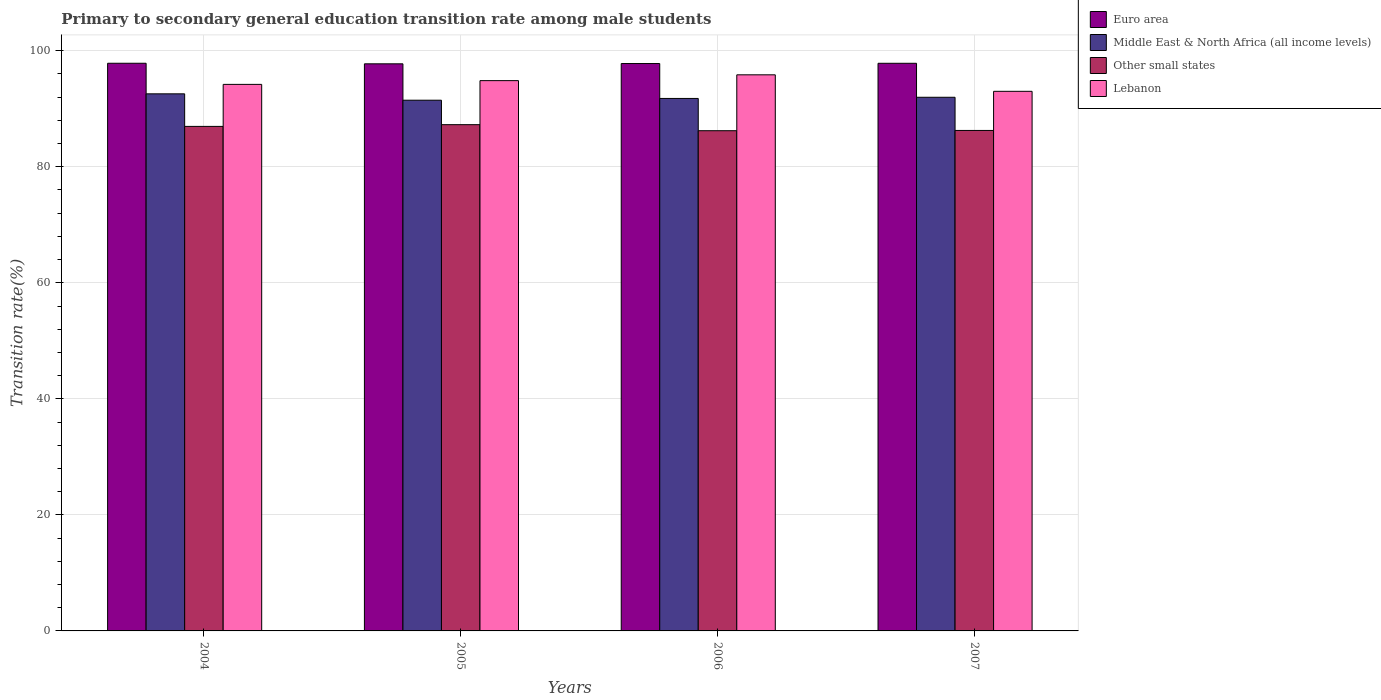How many different coloured bars are there?
Offer a terse response. 4. Are the number of bars on each tick of the X-axis equal?
Provide a succinct answer. Yes. How many bars are there on the 1st tick from the right?
Offer a very short reply. 4. What is the transition rate in Middle East & North Africa (all income levels) in 2007?
Offer a terse response. 91.98. Across all years, what is the maximum transition rate in Lebanon?
Make the answer very short. 95.85. Across all years, what is the minimum transition rate in Other small states?
Your response must be concise. 86.22. In which year was the transition rate in Euro area maximum?
Provide a short and direct response. 2004. In which year was the transition rate in Other small states minimum?
Offer a terse response. 2006. What is the total transition rate in Other small states in the graph?
Your answer should be very brief. 346.7. What is the difference between the transition rate in Middle East & North Africa (all income levels) in 2004 and that in 2006?
Offer a very short reply. 0.79. What is the difference between the transition rate in Euro area in 2005 and the transition rate in Lebanon in 2006?
Provide a succinct answer. 1.9. What is the average transition rate in Other small states per year?
Your answer should be compact. 86.68. In the year 2006, what is the difference between the transition rate in Other small states and transition rate in Middle East & North Africa (all income levels)?
Provide a short and direct response. -5.56. What is the ratio of the transition rate in Lebanon in 2005 to that in 2006?
Your answer should be compact. 0.99. What is the difference between the highest and the second highest transition rate in Euro area?
Your answer should be very brief. 0. What is the difference between the highest and the lowest transition rate in Other small states?
Your response must be concise. 1.04. In how many years, is the transition rate in Lebanon greater than the average transition rate in Lebanon taken over all years?
Ensure brevity in your answer.  2. Is it the case that in every year, the sum of the transition rate in Lebanon and transition rate in Middle East & North Africa (all income levels) is greater than the sum of transition rate in Other small states and transition rate in Euro area?
Make the answer very short. Yes. What does the 2nd bar from the left in 2006 represents?
Ensure brevity in your answer.  Middle East & North Africa (all income levels). What does the 4th bar from the right in 2004 represents?
Your answer should be compact. Euro area. How many years are there in the graph?
Give a very brief answer. 4. What is the difference between two consecutive major ticks on the Y-axis?
Your response must be concise. 20. Are the values on the major ticks of Y-axis written in scientific E-notation?
Offer a very short reply. No. Does the graph contain any zero values?
Give a very brief answer. No. Where does the legend appear in the graph?
Make the answer very short. Top right. How many legend labels are there?
Give a very brief answer. 4. How are the legend labels stacked?
Ensure brevity in your answer.  Vertical. What is the title of the graph?
Your response must be concise. Primary to secondary general education transition rate among male students. What is the label or title of the X-axis?
Keep it short and to the point. Years. What is the label or title of the Y-axis?
Ensure brevity in your answer.  Transition rate(%). What is the Transition rate(%) in Euro area in 2004?
Your response must be concise. 97.84. What is the Transition rate(%) of Middle East & North Africa (all income levels) in 2004?
Your answer should be compact. 92.57. What is the Transition rate(%) in Other small states in 2004?
Keep it short and to the point. 86.96. What is the Transition rate(%) in Lebanon in 2004?
Your answer should be compact. 94.2. What is the Transition rate(%) of Euro area in 2005?
Provide a short and direct response. 97.75. What is the Transition rate(%) of Middle East & North Africa (all income levels) in 2005?
Your response must be concise. 91.48. What is the Transition rate(%) in Other small states in 2005?
Provide a succinct answer. 87.26. What is the Transition rate(%) of Lebanon in 2005?
Provide a succinct answer. 94.85. What is the Transition rate(%) of Euro area in 2006?
Your answer should be compact. 97.79. What is the Transition rate(%) of Middle East & North Africa (all income levels) in 2006?
Make the answer very short. 91.78. What is the Transition rate(%) in Other small states in 2006?
Keep it short and to the point. 86.22. What is the Transition rate(%) in Lebanon in 2006?
Ensure brevity in your answer.  95.85. What is the Transition rate(%) in Euro area in 2007?
Give a very brief answer. 97.84. What is the Transition rate(%) in Middle East & North Africa (all income levels) in 2007?
Offer a terse response. 91.98. What is the Transition rate(%) of Other small states in 2007?
Offer a very short reply. 86.26. What is the Transition rate(%) in Lebanon in 2007?
Keep it short and to the point. 93.01. Across all years, what is the maximum Transition rate(%) in Euro area?
Give a very brief answer. 97.84. Across all years, what is the maximum Transition rate(%) in Middle East & North Africa (all income levels)?
Provide a succinct answer. 92.57. Across all years, what is the maximum Transition rate(%) in Other small states?
Your answer should be very brief. 87.26. Across all years, what is the maximum Transition rate(%) in Lebanon?
Make the answer very short. 95.85. Across all years, what is the minimum Transition rate(%) in Euro area?
Offer a very short reply. 97.75. Across all years, what is the minimum Transition rate(%) of Middle East & North Africa (all income levels)?
Offer a terse response. 91.48. Across all years, what is the minimum Transition rate(%) of Other small states?
Offer a terse response. 86.22. Across all years, what is the minimum Transition rate(%) of Lebanon?
Your answer should be compact. 93.01. What is the total Transition rate(%) of Euro area in the graph?
Offer a terse response. 391.22. What is the total Transition rate(%) of Middle East & North Africa (all income levels) in the graph?
Provide a short and direct response. 367.81. What is the total Transition rate(%) in Other small states in the graph?
Provide a succinct answer. 346.7. What is the total Transition rate(%) in Lebanon in the graph?
Provide a short and direct response. 377.91. What is the difference between the Transition rate(%) in Euro area in 2004 and that in 2005?
Your answer should be very brief. 0.1. What is the difference between the Transition rate(%) in Middle East & North Africa (all income levels) in 2004 and that in 2005?
Offer a terse response. 1.1. What is the difference between the Transition rate(%) in Other small states in 2004 and that in 2005?
Your answer should be very brief. -0.3. What is the difference between the Transition rate(%) of Lebanon in 2004 and that in 2005?
Make the answer very short. -0.65. What is the difference between the Transition rate(%) in Euro area in 2004 and that in 2006?
Offer a terse response. 0.05. What is the difference between the Transition rate(%) of Middle East & North Africa (all income levels) in 2004 and that in 2006?
Your answer should be compact. 0.79. What is the difference between the Transition rate(%) in Other small states in 2004 and that in 2006?
Give a very brief answer. 0.74. What is the difference between the Transition rate(%) of Lebanon in 2004 and that in 2006?
Provide a short and direct response. -1.65. What is the difference between the Transition rate(%) in Euro area in 2004 and that in 2007?
Provide a short and direct response. 0. What is the difference between the Transition rate(%) in Middle East & North Africa (all income levels) in 2004 and that in 2007?
Your answer should be compact. 0.59. What is the difference between the Transition rate(%) of Other small states in 2004 and that in 2007?
Keep it short and to the point. 0.7. What is the difference between the Transition rate(%) of Lebanon in 2004 and that in 2007?
Provide a short and direct response. 1.2. What is the difference between the Transition rate(%) of Euro area in 2005 and that in 2006?
Ensure brevity in your answer.  -0.05. What is the difference between the Transition rate(%) in Middle East & North Africa (all income levels) in 2005 and that in 2006?
Provide a short and direct response. -0.3. What is the difference between the Transition rate(%) in Other small states in 2005 and that in 2006?
Offer a very short reply. 1.04. What is the difference between the Transition rate(%) of Lebanon in 2005 and that in 2006?
Offer a very short reply. -1. What is the difference between the Transition rate(%) in Euro area in 2005 and that in 2007?
Your answer should be very brief. -0.09. What is the difference between the Transition rate(%) in Middle East & North Africa (all income levels) in 2005 and that in 2007?
Offer a terse response. -0.5. What is the difference between the Transition rate(%) of Other small states in 2005 and that in 2007?
Provide a short and direct response. 1. What is the difference between the Transition rate(%) of Lebanon in 2005 and that in 2007?
Provide a short and direct response. 1.84. What is the difference between the Transition rate(%) of Euro area in 2006 and that in 2007?
Keep it short and to the point. -0.05. What is the difference between the Transition rate(%) in Middle East & North Africa (all income levels) in 2006 and that in 2007?
Your answer should be very brief. -0.2. What is the difference between the Transition rate(%) of Other small states in 2006 and that in 2007?
Your answer should be very brief. -0.04. What is the difference between the Transition rate(%) of Lebanon in 2006 and that in 2007?
Your answer should be compact. 2.84. What is the difference between the Transition rate(%) in Euro area in 2004 and the Transition rate(%) in Middle East & North Africa (all income levels) in 2005?
Keep it short and to the point. 6.37. What is the difference between the Transition rate(%) of Euro area in 2004 and the Transition rate(%) of Other small states in 2005?
Make the answer very short. 10.59. What is the difference between the Transition rate(%) of Euro area in 2004 and the Transition rate(%) of Lebanon in 2005?
Your answer should be very brief. 2.99. What is the difference between the Transition rate(%) in Middle East & North Africa (all income levels) in 2004 and the Transition rate(%) in Other small states in 2005?
Give a very brief answer. 5.32. What is the difference between the Transition rate(%) in Middle East & North Africa (all income levels) in 2004 and the Transition rate(%) in Lebanon in 2005?
Ensure brevity in your answer.  -2.27. What is the difference between the Transition rate(%) of Other small states in 2004 and the Transition rate(%) of Lebanon in 2005?
Ensure brevity in your answer.  -7.89. What is the difference between the Transition rate(%) in Euro area in 2004 and the Transition rate(%) in Middle East & North Africa (all income levels) in 2006?
Offer a terse response. 6.06. What is the difference between the Transition rate(%) in Euro area in 2004 and the Transition rate(%) in Other small states in 2006?
Make the answer very short. 11.63. What is the difference between the Transition rate(%) in Euro area in 2004 and the Transition rate(%) in Lebanon in 2006?
Offer a very short reply. 1.99. What is the difference between the Transition rate(%) in Middle East & North Africa (all income levels) in 2004 and the Transition rate(%) in Other small states in 2006?
Your answer should be very brief. 6.36. What is the difference between the Transition rate(%) in Middle East & North Africa (all income levels) in 2004 and the Transition rate(%) in Lebanon in 2006?
Ensure brevity in your answer.  -3.28. What is the difference between the Transition rate(%) in Other small states in 2004 and the Transition rate(%) in Lebanon in 2006?
Your response must be concise. -8.89. What is the difference between the Transition rate(%) in Euro area in 2004 and the Transition rate(%) in Middle East & North Africa (all income levels) in 2007?
Your response must be concise. 5.86. What is the difference between the Transition rate(%) in Euro area in 2004 and the Transition rate(%) in Other small states in 2007?
Ensure brevity in your answer.  11.58. What is the difference between the Transition rate(%) of Euro area in 2004 and the Transition rate(%) of Lebanon in 2007?
Offer a terse response. 4.84. What is the difference between the Transition rate(%) of Middle East & North Africa (all income levels) in 2004 and the Transition rate(%) of Other small states in 2007?
Provide a short and direct response. 6.31. What is the difference between the Transition rate(%) of Middle East & North Africa (all income levels) in 2004 and the Transition rate(%) of Lebanon in 2007?
Offer a very short reply. -0.43. What is the difference between the Transition rate(%) in Other small states in 2004 and the Transition rate(%) in Lebanon in 2007?
Your answer should be compact. -6.05. What is the difference between the Transition rate(%) of Euro area in 2005 and the Transition rate(%) of Middle East & North Africa (all income levels) in 2006?
Your response must be concise. 5.97. What is the difference between the Transition rate(%) of Euro area in 2005 and the Transition rate(%) of Other small states in 2006?
Make the answer very short. 11.53. What is the difference between the Transition rate(%) of Euro area in 2005 and the Transition rate(%) of Lebanon in 2006?
Your answer should be very brief. 1.9. What is the difference between the Transition rate(%) in Middle East & North Africa (all income levels) in 2005 and the Transition rate(%) in Other small states in 2006?
Your answer should be very brief. 5.26. What is the difference between the Transition rate(%) in Middle East & North Africa (all income levels) in 2005 and the Transition rate(%) in Lebanon in 2006?
Keep it short and to the point. -4.37. What is the difference between the Transition rate(%) of Other small states in 2005 and the Transition rate(%) of Lebanon in 2006?
Make the answer very short. -8.59. What is the difference between the Transition rate(%) of Euro area in 2005 and the Transition rate(%) of Middle East & North Africa (all income levels) in 2007?
Your answer should be compact. 5.77. What is the difference between the Transition rate(%) in Euro area in 2005 and the Transition rate(%) in Other small states in 2007?
Give a very brief answer. 11.48. What is the difference between the Transition rate(%) of Euro area in 2005 and the Transition rate(%) of Lebanon in 2007?
Keep it short and to the point. 4.74. What is the difference between the Transition rate(%) in Middle East & North Africa (all income levels) in 2005 and the Transition rate(%) in Other small states in 2007?
Your answer should be very brief. 5.21. What is the difference between the Transition rate(%) in Middle East & North Africa (all income levels) in 2005 and the Transition rate(%) in Lebanon in 2007?
Your answer should be very brief. -1.53. What is the difference between the Transition rate(%) in Other small states in 2005 and the Transition rate(%) in Lebanon in 2007?
Your answer should be compact. -5.75. What is the difference between the Transition rate(%) of Euro area in 2006 and the Transition rate(%) of Middle East & North Africa (all income levels) in 2007?
Your answer should be very brief. 5.81. What is the difference between the Transition rate(%) of Euro area in 2006 and the Transition rate(%) of Other small states in 2007?
Your answer should be compact. 11.53. What is the difference between the Transition rate(%) of Euro area in 2006 and the Transition rate(%) of Lebanon in 2007?
Your answer should be compact. 4.79. What is the difference between the Transition rate(%) in Middle East & North Africa (all income levels) in 2006 and the Transition rate(%) in Other small states in 2007?
Provide a short and direct response. 5.52. What is the difference between the Transition rate(%) in Middle East & North Africa (all income levels) in 2006 and the Transition rate(%) in Lebanon in 2007?
Offer a very short reply. -1.23. What is the difference between the Transition rate(%) in Other small states in 2006 and the Transition rate(%) in Lebanon in 2007?
Make the answer very short. -6.79. What is the average Transition rate(%) in Euro area per year?
Your answer should be compact. 97.81. What is the average Transition rate(%) in Middle East & North Africa (all income levels) per year?
Keep it short and to the point. 91.95. What is the average Transition rate(%) in Other small states per year?
Make the answer very short. 86.68. What is the average Transition rate(%) of Lebanon per year?
Your response must be concise. 94.48. In the year 2004, what is the difference between the Transition rate(%) of Euro area and Transition rate(%) of Middle East & North Africa (all income levels)?
Offer a very short reply. 5.27. In the year 2004, what is the difference between the Transition rate(%) in Euro area and Transition rate(%) in Other small states?
Offer a very short reply. 10.88. In the year 2004, what is the difference between the Transition rate(%) of Euro area and Transition rate(%) of Lebanon?
Ensure brevity in your answer.  3.64. In the year 2004, what is the difference between the Transition rate(%) in Middle East & North Africa (all income levels) and Transition rate(%) in Other small states?
Give a very brief answer. 5.61. In the year 2004, what is the difference between the Transition rate(%) of Middle East & North Africa (all income levels) and Transition rate(%) of Lebanon?
Your response must be concise. -1.63. In the year 2004, what is the difference between the Transition rate(%) of Other small states and Transition rate(%) of Lebanon?
Keep it short and to the point. -7.24. In the year 2005, what is the difference between the Transition rate(%) of Euro area and Transition rate(%) of Middle East & North Africa (all income levels)?
Your answer should be compact. 6.27. In the year 2005, what is the difference between the Transition rate(%) in Euro area and Transition rate(%) in Other small states?
Ensure brevity in your answer.  10.49. In the year 2005, what is the difference between the Transition rate(%) in Euro area and Transition rate(%) in Lebanon?
Keep it short and to the point. 2.9. In the year 2005, what is the difference between the Transition rate(%) of Middle East & North Africa (all income levels) and Transition rate(%) of Other small states?
Give a very brief answer. 4.22. In the year 2005, what is the difference between the Transition rate(%) in Middle East & North Africa (all income levels) and Transition rate(%) in Lebanon?
Offer a very short reply. -3.37. In the year 2005, what is the difference between the Transition rate(%) in Other small states and Transition rate(%) in Lebanon?
Your answer should be very brief. -7.59. In the year 2006, what is the difference between the Transition rate(%) of Euro area and Transition rate(%) of Middle East & North Africa (all income levels)?
Make the answer very short. 6.01. In the year 2006, what is the difference between the Transition rate(%) in Euro area and Transition rate(%) in Other small states?
Your answer should be very brief. 11.58. In the year 2006, what is the difference between the Transition rate(%) in Euro area and Transition rate(%) in Lebanon?
Ensure brevity in your answer.  1.94. In the year 2006, what is the difference between the Transition rate(%) in Middle East & North Africa (all income levels) and Transition rate(%) in Other small states?
Your answer should be compact. 5.56. In the year 2006, what is the difference between the Transition rate(%) of Middle East & North Africa (all income levels) and Transition rate(%) of Lebanon?
Offer a terse response. -4.07. In the year 2006, what is the difference between the Transition rate(%) in Other small states and Transition rate(%) in Lebanon?
Provide a short and direct response. -9.63. In the year 2007, what is the difference between the Transition rate(%) in Euro area and Transition rate(%) in Middle East & North Africa (all income levels)?
Keep it short and to the point. 5.86. In the year 2007, what is the difference between the Transition rate(%) in Euro area and Transition rate(%) in Other small states?
Give a very brief answer. 11.58. In the year 2007, what is the difference between the Transition rate(%) of Euro area and Transition rate(%) of Lebanon?
Offer a very short reply. 4.83. In the year 2007, what is the difference between the Transition rate(%) in Middle East & North Africa (all income levels) and Transition rate(%) in Other small states?
Keep it short and to the point. 5.72. In the year 2007, what is the difference between the Transition rate(%) in Middle East & North Africa (all income levels) and Transition rate(%) in Lebanon?
Provide a succinct answer. -1.03. In the year 2007, what is the difference between the Transition rate(%) in Other small states and Transition rate(%) in Lebanon?
Your response must be concise. -6.74. What is the ratio of the Transition rate(%) of Other small states in 2004 to that in 2005?
Your answer should be compact. 1. What is the ratio of the Transition rate(%) in Lebanon in 2004 to that in 2005?
Keep it short and to the point. 0.99. What is the ratio of the Transition rate(%) in Middle East & North Africa (all income levels) in 2004 to that in 2006?
Your answer should be compact. 1.01. What is the ratio of the Transition rate(%) in Other small states in 2004 to that in 2006?
Provide a succinct answer. 1.01. What is the ratio of the Transition rate(%) of Lebanon in 2004 to that in 2006?
Provide a succinct answer. 0.98. What is the ratio of the Transition rate(%) of Euro area in 2004 to that in 2007?
Offer a very short reply. 1. What is the ratio of the Transition rate(%) in Lebanon in 2004 to that in 2007?
Provide a succinct answer. 1.01. What is the ratio of the Transition rate(%) in Euro area in 2005 to that in 2006?
Keep it short and to the point. 1. What is the ratio of the Transition rate(%) in Other small states in 2005 to that in 2006?
Your answer should be compact. 1.01. What is the ratio of the Transition rate(%) of Middle East & North Africa (all income levels) in 2005 to that in 2007?
Your answer should be very brief. 0.99. What is the ratio of the Transition rate(%) in Other small states in 2005 to that in 2007?
Give a very brief answer. 1.01. What is the ratio of the Transition rate(%) of Lebanon in 2005 to that in 2007?
Ensure brevity in your answer.  1.02. What is the ratio of the Transition rate(%) of Euro area in 2006 to that in 2007?
Give a very brief answer. 1. What is the ratio of the Transition rate(%) of Middle East & North Africa (all income levels) in 2006 to that in 2007?
Make the answer very short. 1. What is the ratio of the Transition rate(%) of Lebanon in 2006 to that in 2007?
Offer a very short reply. 1.03. What is the difference between the highest and the second highest Transition rate(%) of Euro area?
Offer a terse response. 0. What is the difference between the highest and the second highest Transition rate(%) in Middle East & North Africa (all income levels)?
Offer a very short reply. 0.59. What is the difference between the highest and the second highest Transition rate(%) of Other small states?
Give a very brief answer. 0.3. What is the difference between the highest and the lowest Transition rate(%) of Euro area?
Give a very brief answer. 0.1. What is the difference between the highest and the lowest Transition rate(%) in Middle East & North Africa (all income levels)?
Ensure brevity in your answer.  1.1. What is the difference between the highest and the lowest Transition rate(%) in Other small states?
Your answer should be very brief. 1.04. What is the difference between the highest and the lowest Transition rate(%) in Lebanon?
Your response must be concise. 2.84. 